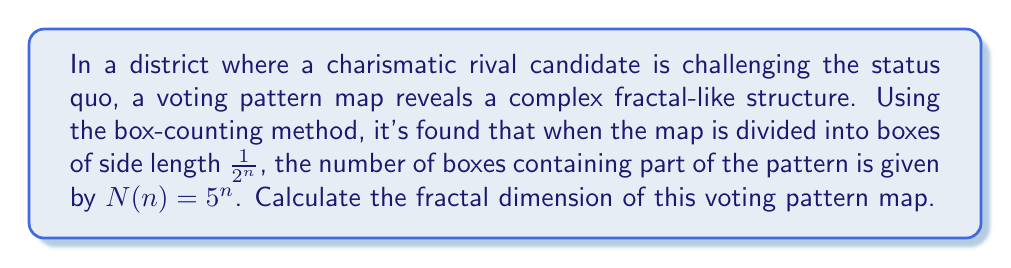Can you answer this question? To calculate the fractal dimension using the box-counting method, we follow these steps:

1) The general formula for fractal dimension $D$ is:

   $$D = \lim_{n \to \infty} \frac{\log N(n)}{\log(2^n)}$$

   where $N(n)$ is the number of boxes of side length $\frac{1}{2^n}$ that contain part of the fractal.

2) In this case, we're given that $N(n) = 5^n$. Let's substitute this into our formula:

   $$D = \lim_{n \to \infty} \frac{\log(5^n)}{\log(2^n)}$$

3) Using the logarithm property $\log(a^b) = b\log(a)$, we can simplify:

   $$D = \lim_{n \to \infty} \frac{n\log(5)}{n\log(2)}$$

4) The $n$ cancels out in the numerator and denominator:

   $$D = \frac{\log(5)}{\log(2)}$$

5) This is our final answer. We can calculate this value:

   $$D \approx 2.3219$$

This fractal dimension between 2 and 3 indicates a very complex voting pattern, reflecting the disruptive influence of the charismatic rival candidate.
Answer: $\frac{\log(5)}{\log(2)} \approx 2.3219$ 